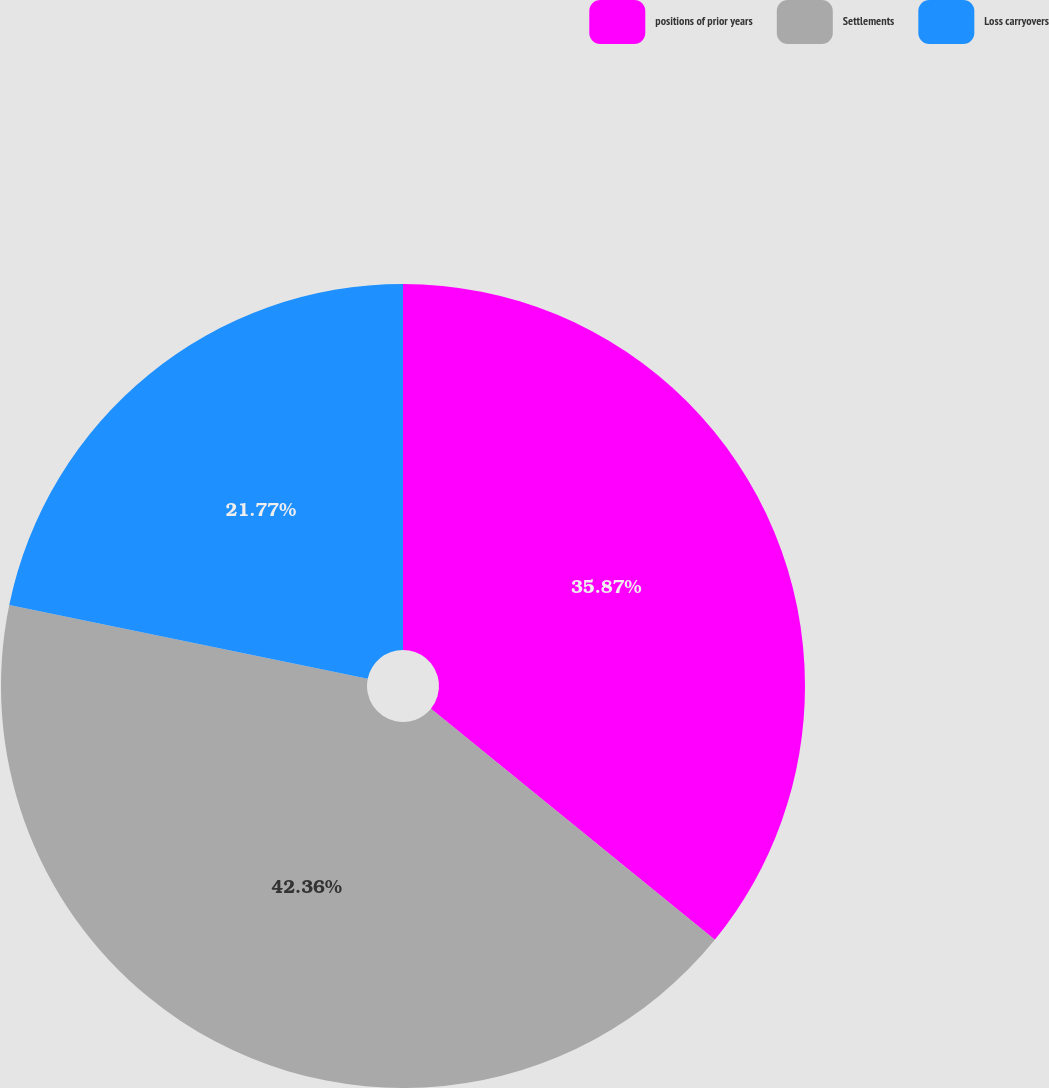<chart> <loc_0><loc_0><loc_500><loc_500><pie_chart><fcel>positions of prior years<fcel>Settlements<fcel>Loss carryovers<nl><fcel>35.87%<fcel>42.36%<fcel>21.77%<nl></chart> 